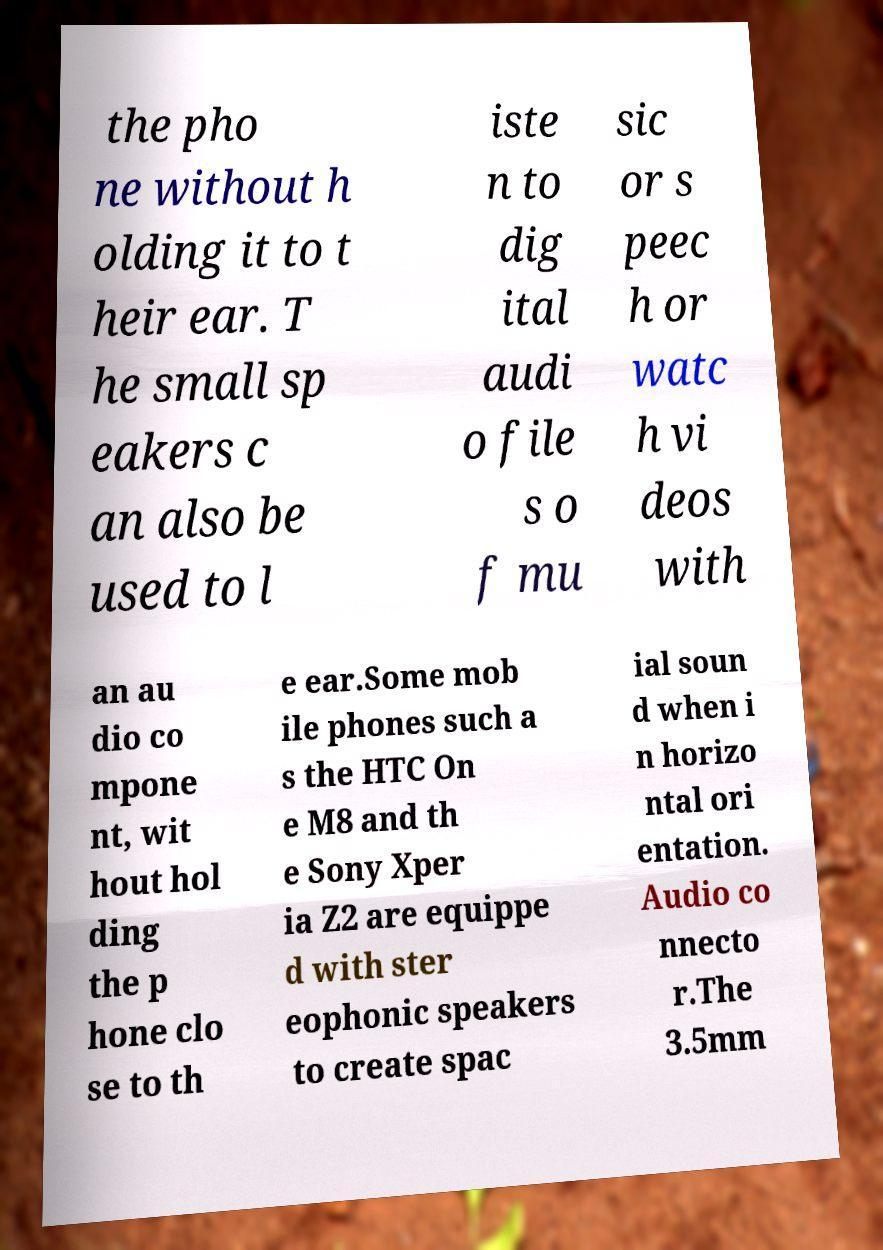Could you extract and type out the text from this image? the pho ne without h olding it to t heir ear. T he small sp eakers c an also be used to l iste n to dig ital audi o file s o f mu sic or s peec h or watc h vi deos with an au dio co mpone nt, wit hout hol ding the p hone clo se to th e ear.Some mob ile phones such a s the HTC On e M8 and th e Sony Xper ia Z2 are equippe d with ster eophonic speakers to create spac ial soun d when i n horizo ntal ori entation. Audio co nnecto r.The 3.5mm 